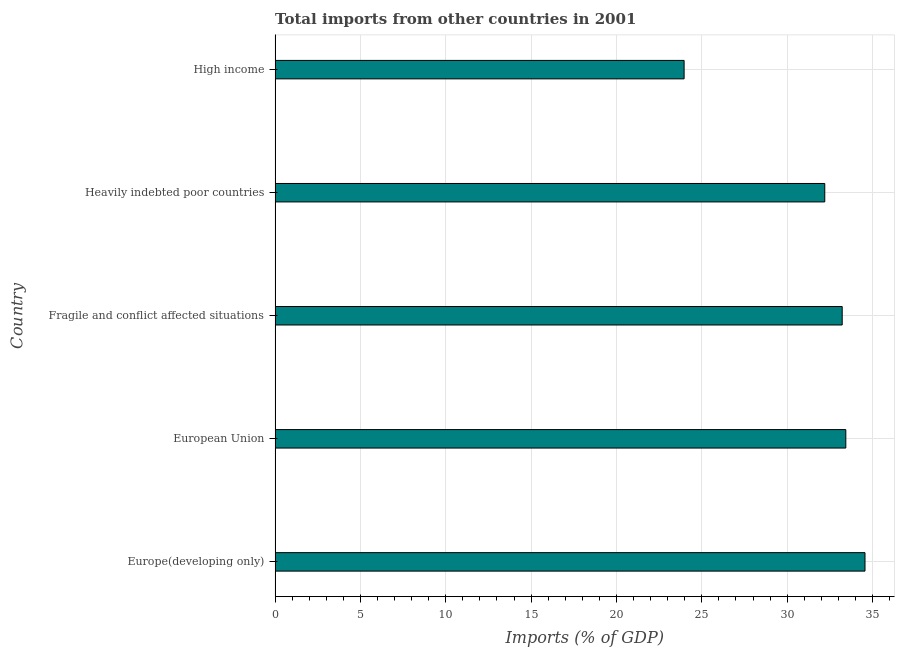Does the graph contain any zero values?
Make the answer very short. No. Does the graph contain grids?
Your answer should be very brief. Yes. What is the title of the graph?
Give a very brief answer. Total imports from other countries in 2001. What is the label or title of the X-axis?
Provide a succinct answer. Imports (% of GDP). What is the label or title of the Y-axis?
Provide a succinct answer. Country. What is the total imports in European Union?
Offer a very short reply. 33.43. Across all countries, what is the maximum total imports?
Your response must be concise. 34.56. Across all countries, what is the minimum total imports?
Your response must be concise. 23.96. In which country was the total imports maximum?
Provide a succinct answer. Europe(developing only). In which country was the total imports minimum?
Provide a succinct answer. High income. What is the sum of the total imports?
Offer a very short reply. 157.38. What is the difference between the total imports in Europe(developing only) and Heavily indebted poor countries?
Your answer should be compact. 2.36. What is the average total imports per country?
Keep it short and to the point. 31.48. What is the median total imports?
Your answer should be very brief. 33.22. What is the ratio of the total imports in Fragile and conflict affected situations to that in High income?
Give a very brief answer. 1.39. Is the difference between the total imports in European Union and Fragile and conflict affected situations greater than the difference between any two countries?
Give a very brief answer. No. What is the difference between the highest and the second highest total imports?
Ensure brevity in your answer.  1.12. What is the difference between the highest and the lowest total imports?
Your answer should be very brief. 10.6. In how many countries, is the total imports greater than the average total imports taken over all countries?
Offer a terse response. 4. How many bars are there?
Make the answer very short. 5. Are the values on the major ticks of X-axis written in scientific E-notation?
Ensure brevity in your answer.  No. What is the Imports (% of GDP) of Europe(developing only)?
Ensure brevity in your answer.  34.56. What is the Imports (% of GDP) in European Union?
Offer a terse response. 33.43. What is the Imports (% of GDP) of Fragile and conflict affected situations?
Your answer should be very brief. 33.22. What is the Imports (% of GDP) in Heavily indebted poor countries?
Your answer should be compact. 32.2. What is the Imports (% of GDP) of High income?
Make the answer very short. 23.96. What is the difference between the Imports (% of GDP) in Europe(developing only) and European Union?
Your answer should be very brief. 1.12. What is the difference between the Imports (% of GDP) in Europe(developing only) and Fragile and conflict affected situations?
Your answer should be very brief. 1.34. What is the difference between the Imports (% of GDP) in Europe(developing only) and Heavily indebted poor countries?
Your response must be concise. 2.36. What is the difference between the Imports (% of GDP) in Europe(developing only) and High income?
Keep it short and to the point. 10.6. What is the difference between the Imports (% of GDP) in European Union and Fragile and conflict affected situations?
Provide a succinct answer. 0.21. What is the difference between the Imports (% of GDP) in European Union and Heavily indebted poor countries?
Keep it short and to the point. 1.23. What is the difference between the Imports (% of GDP) in European Union and High income?
Give a very brief answer. 9.47. What is the difference between the Imports (% of GDP) in Fragile and conflict affected situations and Heavily indebted poor countries?
Give a very brief answer. 1.02. What is the difference between the Imports (% of GDP) in Fragile and conflict affected situations and High income?
Provide a short and direct response. 9.26. What is the difference between the Imports (% of GDP) in Heavily indebted poor countries and High income?
Your answer should be very brief. 8.24. What is the ratio of the Imports (% of GDP) in Europe(developing only) to that in European Union?
Give a very brief answer. 1.03. What is the ratio of the Imports (% of GDP) in Europe(developing only) to that in Fragile and conflict affected situations?
Keep it short and to the point. 1.04. What is the ratio of the Imports (% of GDP) in Europe(developing only) to that in Heavily indebted poor countries?
Give a very brief answer. 1.07. What is the ratio of the Imports (% of GDP) in Europe(developing only) to that in High income?
Offer a very short reply. 1.44. What is the ratio of the Imports (% of GDP) in European Union to that in Fragile and conflict affected situations?
Provide a succinct answer. 1.01. What is the ratio of the Imports (% of GDP) in European Union to that in Heavily indebted poor countries?
Provide a succinct answer. 1.04. What is the ratio of the Imports (% of GDP) in European Union to that in High income?
Ensure brevity in your answer.  1.4. What is the ratio of the Imports (% of GDP) in Fragile and conflict affected situations to that in Heavily indebted poor countries?
Provide a succinct answer. 1.03. What is the ratio of the Imports (% of GDP) in Fragile and conflict affected situations to that in High income?
Your answer should be compact. 1.39. What is the ratio of the Imports (% of GDP) in Heavily indebted poor countries to that in High income?
Keep it short and to the point. 1.34. 